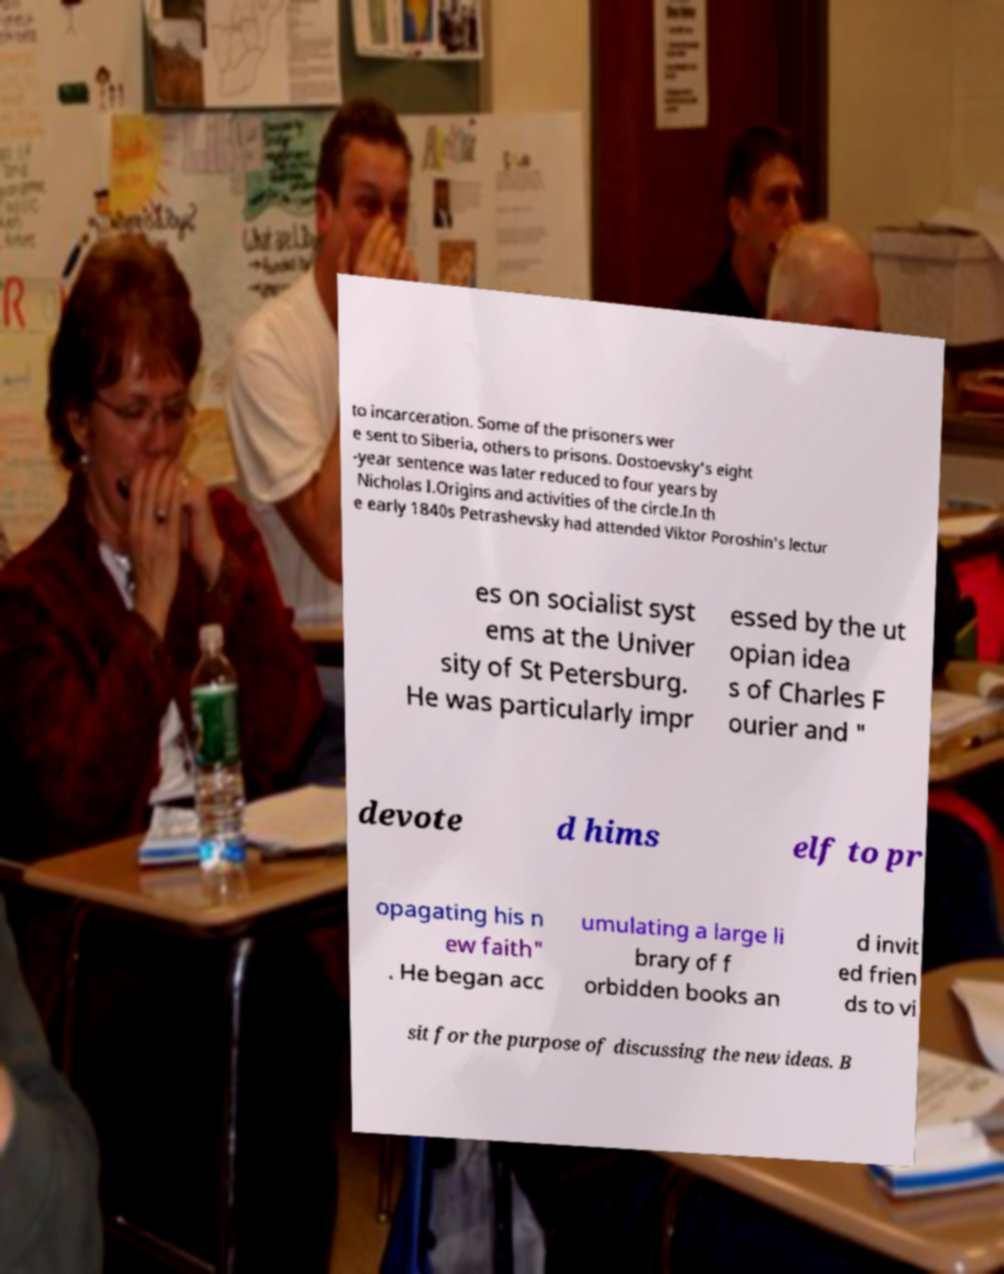Could you assist in decoding the text presented in this image and type it out clearly? to incarceration. Some of the prisoners wer e sent to Siberia, others to prisons. Dostoevsky's eight -year sentence was later reduced to four years by Nicholas I.Origins and activities of the circle.In th e early 1840s Petrashevsky had attended Viktor Poroshin's lectur es on socialist syst ems at the Univer sity of St Petersburg. He was particularly impr essed by the ut opian idea s of Charles F ourier and " devote d hims elf to pr opagating his n ew faith" . He began acc umulating a large li brary of f orbidden books an d invit ed frien ds to vi sit for the purpose of discussing the new ideas. B 